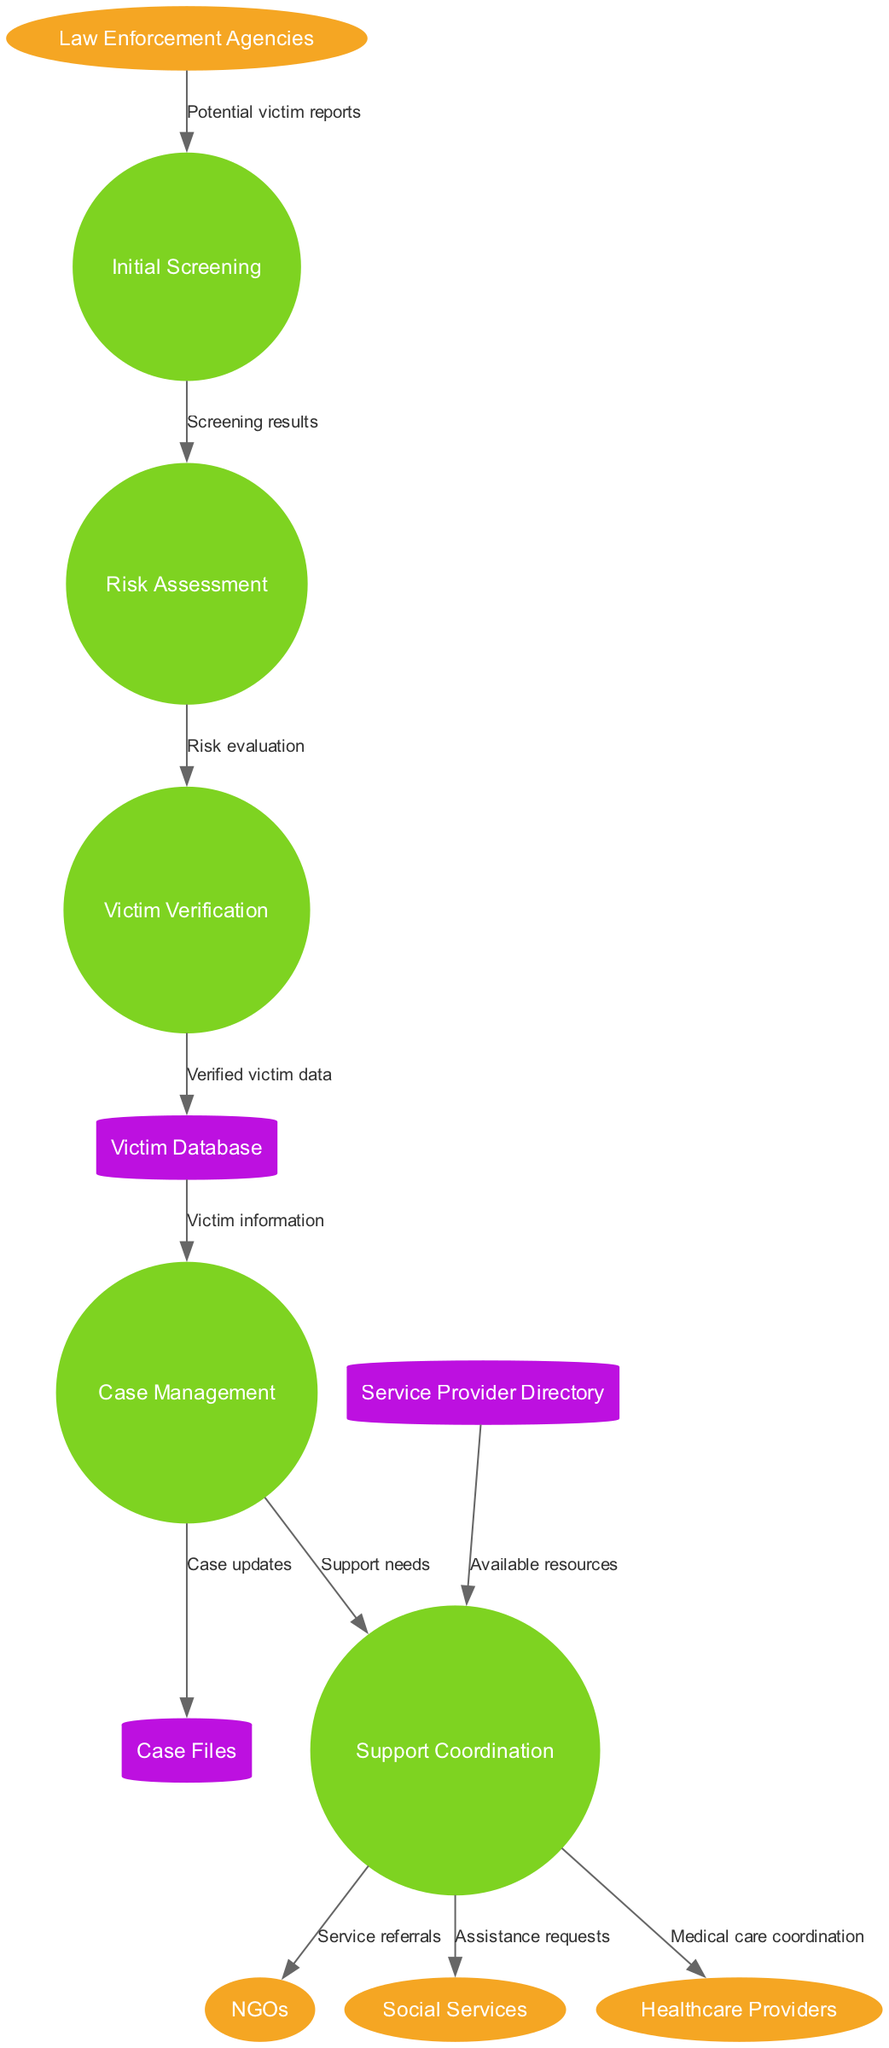What are the external entities in this diagram? The diagram lists external entities as Law Enforcement Agencies, NGOs, Social Services, and Healthcare Providers, providing insights into the stakeholders involved in the victim identification and support process.
Answer: Law Enforcement Agencies, NGOs, Social Services, Healthcare Providers How many processes are represented in the diagram? The diagram outlines five distinct processes: Initial Screening, Risk Assessment, Victim Verification, Case Management, and Support Coordination. Counting these processes gives us the total number of processes.
Answer: 5 What data store receives verified victim data? Verified victim data flows into the Victim Database during the victim verification process, indicating where this information is stored for future reference and access.
Answer: Victim Database What is the flow that comes from the Risk Assessment process? The flow from the Risk Assessment process is labeled "Risk evaluation" and goes to the Victim Verification process, indicating a decision point based on assessed risk.
Answer: Risk evaluation Which external entity is involved in service referrals? The Support Coordination process sends service referrals to NGOs, highlighting the role NGOs play in providing direct help to identified victims.
Answer: NGOs What type of data does the Case Management process send to Case Files? The Case Management process sends "Case updates" to the Case Files data store, reflecting the critical information needed for managing individual cases effectively.
Answer: Case updates What is the relationship between Initial Screening and Risk Assessment? The Initial Screening process provides "Screening results" to the Risk Assessment process, establishing a sequence where initial findings inform further evaluation of a victim's risk.
Answer: Screening results From which data store does Support Coordination receive available resources? The Support Coordination process retrieves "Available resources" from the Service Provider Directory, ensuring that suitable assistance options are accessible during case handling.
Answer: Available resources What is the last process in the flow of victim identification and support services? The last process in this flow is Support Coordination, as it connects with external entities to manage ongoing support for victims after their identification and assessment.
Answer: Support Coordination 